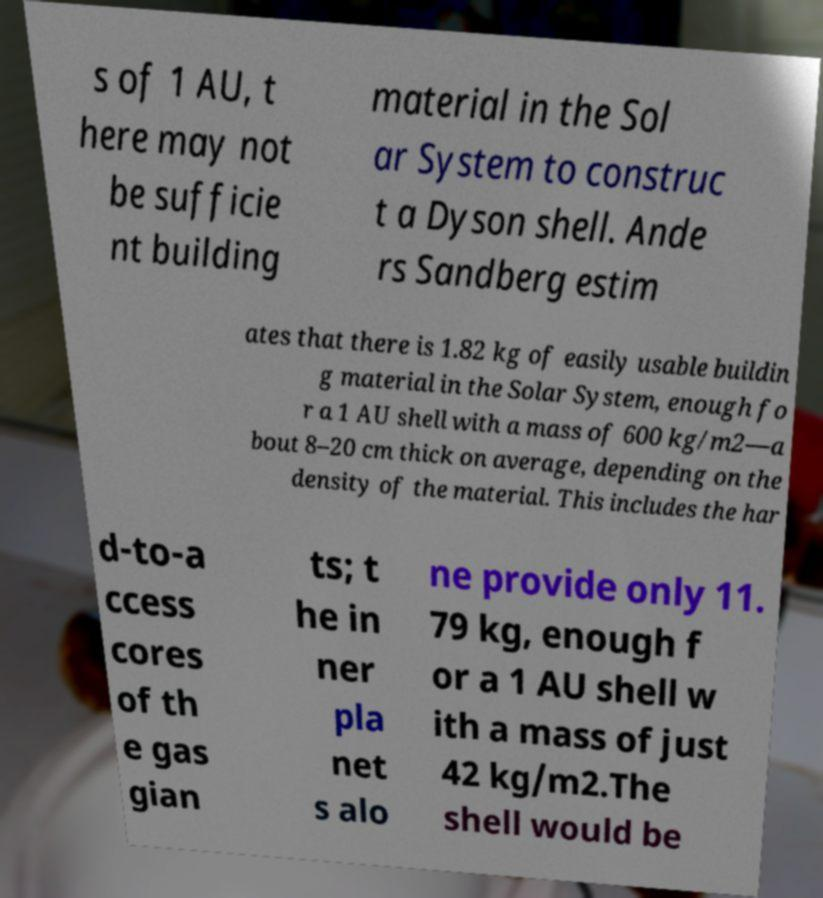Could you extract and type out the text from this image? s of 1 AU, t here may not be sufficie nt building material in the Sol ar System to construc t a Dyson shell. Ande rs Sandberg estim ates that there is 1.82 kg of easily usable buildin g material in the Solar System, enough fo r a 1 AU shell with a mass of 600 kg/m2—a bout 8–20 cm thick on average, depending on the density of the material. This includes the har d-to-a ccess cores of th e gas gian ts; t he in ner pla net s alo ne provide only 11. 79 kg, enough f or a 1 AU shell w ith a mass of just 42 kg/m2.The shell would be 